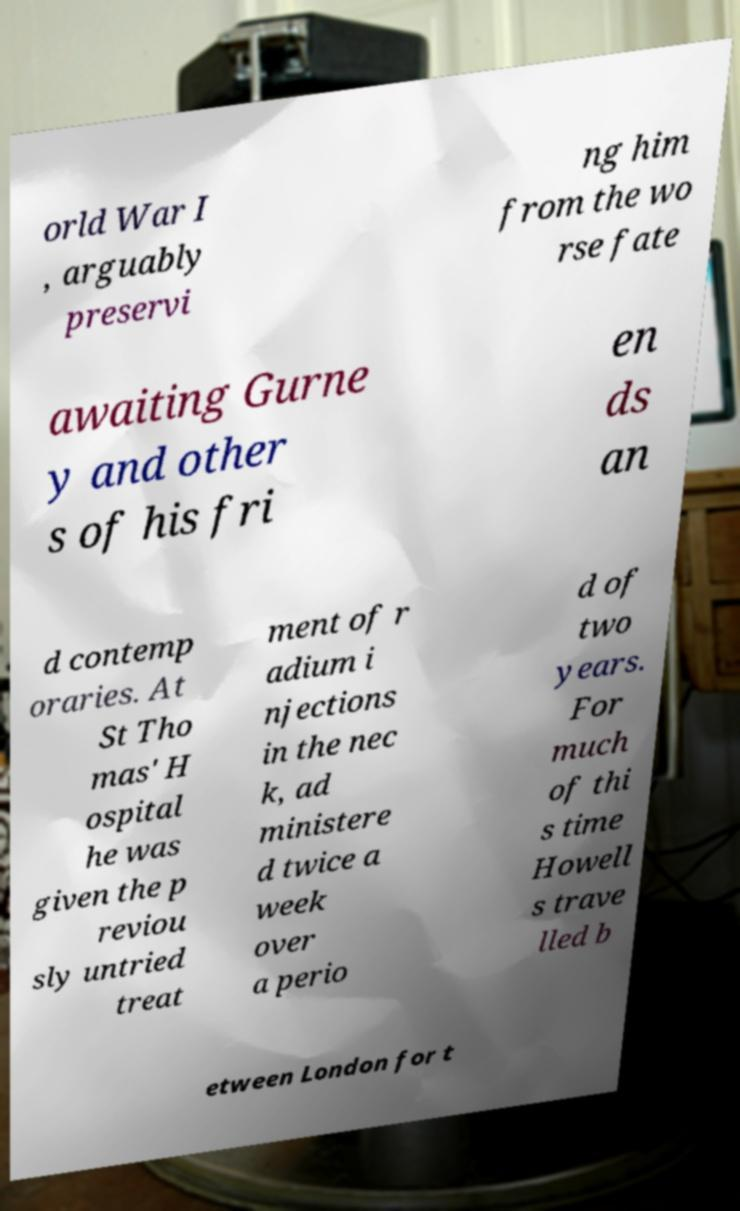What messages or text are displayed in this image? I need them in a readable, typed format. orld War I , arguably preservi ng him from the wo rse fate awaiting Gurne y and other s of his fri en ds an d contemp oraries. At St Tho mas' H ospital he was given the p reviou sly untried treat ment of r adium i njections in the nec k, ad ministere d twice a week over a perio d of two years. For much of thi s time Howell s trave lled b etween London for t 